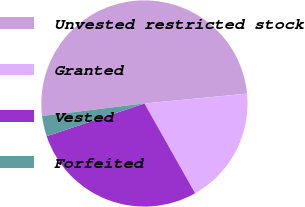Convert chart. <chart><loc_0><loc_0><loc_500><loc_500><pie_chart><fcel>Unvested restricted stock<fcel>Granted<fcel>Vested<fcel>Forfeited<nl><fcel>50.42%<fcel>18.35%<fcel>28.03%<fcel>3.21%<nl></chart> 